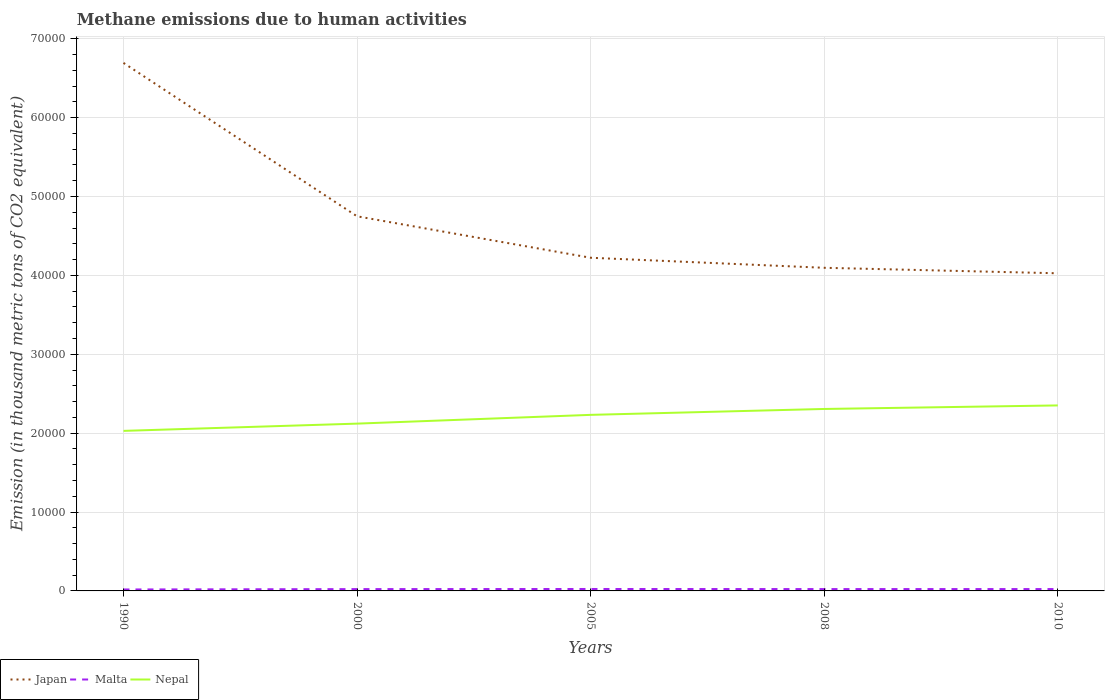Does the line corresponding to Nepal intersect with the line corresponding to Japan?
Ensure brevity in your answer.  No. Across all years, what is the maximum amount of methane emitted in Nepal?
Your answer should be very brief. 2.03e+04. In which year was the amount of methane emitted in Malta maximum?
Make the answer very short. 1990. What is the total amount of methane emitted in Japan in the graph?
Make the answer very short. 1967.7. What is the difference between the highest and the second highest amount of methane emitted in Malta?
Make the answer very short. 61.4. What is the difference between the highest and the lowest amount of methane emitted in Malta?
Make the answer very short. 4. Is the amount of methane emitted in Japan strictly greater than the amount of methane emitted in Malta over the years?
Your answer should be compact. No. How many lines are there?
Your answer should be very brief. 3. Does the graph contain any zero values?
Give a very brief answer. No. What is the title of the graph?
Offer a very short reply. Methane emissions due to human activities. What is the label or title of the Y-axis?
Ensure brevity in your answer.  Emission (in thousand metric tons of CO2 equivalent). What is the Emission (in thousand metric tons of CO2 equivalent) of Japan in 1990?
Offer a terse response. 6.69e+04. What is the Emission (in thousand metric tons of CO2 equivalent) of Malta in 1990?
Give a very brief answer. 183.7. What is the Emission (in thousand metric tons of CO2 equivalent) in Nepal in 1990?
Make the answer very short. 2.03e+04. What is the Emission (in thousand metric tons of CO2 equivalent) in Japan in 2000?
Your answer should be very brief. 4.75e+04. What is the Emission (in thousand metric tons of CO2 equivalent) in Malta in 2000?
Keep it short and to the point. 230.8. What is the Emission (in thousand metric tons of CO2 equivalent) in Nepal in 2000?
Provide a short and direct response. 2.12e+04. What is the Emission (in thousand metric tons of CO2 equivalent) in Japan in 2005?
Keep it short and to the point. 4.22e+04. What is the Emission (in thousand metric tons of CO2 equivalent) in Malta in 2005?
Provide a short and direct response. 245.1. What is the Emission (in thousand metric tons of CO2 equivalent) in Nepal in 2005?
Keep it short and to the point. 2.23e+04. What is the Emission (in thousand metric tons of CO2 equivalent) of Japan in 2008?
Provide a succinct answer. 4.10e+04. What is the Emission (in thousand metric tons of CO2 equivalent) in Malta in 2008?
Provide a short and direct response. 234.5. What is the Emission (in thousand metric tons of CO2 equivalent) of Nepal in 2008?
Make the answer very short. 2.31e+04. What is the Emission (in thousand metric tons of CO2 equivalent) in Japan in 2010?
Keep it short and to the point. 4.03e+04. What is the Emission (in thousand metric tons of CO2 equivalent) of Malta in 2010?
Offer a terse response. 235.4. What is the Emission (in thousand metric tons of CO2 equivalent) of Nepal in 2010?
Give a very brief answer. 2.35e+04. Across all years, what is the maximum Emission (in thousand metric tons of CO2 equivalent) in Japan?
Make the answer very short. 6.69e+04. Across all years, what is the maximum Emission (in thousand metric tons of CO2 equivalent) in Malta?
Offer a terse response. 245.1. Across all years, what is the maximum Emission (in thousand metric tons of CO2 equivalent) in Nepal?
Offer a terse response. 2.35e+04. Across all years, what is the minimum Emission (in thousand metric tons of CO2 equivalent) of Japan?
Provide a short and direct response. 4.03e+04. Across all years, what is the minimum Emission (in thousand metric tons of CO2 equivalent) of Malta?
Your answer should be very brief. 183.7. Across all years, what is the minimum Emission (in thousand metric tons of CO2 equivalent) in Nepal?
Provide a short and direct response. 2.03e+04. What is the total Emission (in thousand metric tons of CO2 equivalent) of Japan in the graph?
Your response must be concise. 2.38e+05. What is the total Emission (in thousand metric tons of CO2 equivalent) in Malta in the graph?
Offer a very short reply. 1129.5. What is the total Emission (in thousand metric tons of CO2 equivalent) in Nepal in the graph?
Give a very brief answer. 1.10e+05. What is the difference between the Emission (in thousand metric tons of CO2 equivalent) in Japan in 1990 and that in 2000?
Your response must be concise. 1.94e+04. What is the difference between the Emission (in thousand metric tons of CO2 equivalent) in Malta in 1990 and that in 2000?
Keep it short and to the point. -47.1. What is the difference between the Emission (in thousand metric tons of CO2 equivalent) of Nepal in 1990 and that in 2000?
Keep it short and to the point. -920.3. What is the difference between the Emission (in thousand metric tons of CO2 equivalent) of Japan in 1990 and that in 2005?
Offer a very short reply. 2.47e+04. What is the difference between the Emission (in thousand metric tons of CO2 equivalent) in Malta in 1990 and that in 2005?
Your answer should be very brief. -61.4. What is the difference between the Emission (in thousand metric tons of CO2 equivalent) in Nepal in 1990 and that in 2005?
Keep it short and to the point. -2031.1. What is the difference between the Emission (in thousand metric tons of CO2 equivalent) of Japan in 1990 and that in 2008?
Your answer should be very brief. 2.60e+04. What is the difference between the Emission (in thousand metric tons of CO2 equivalent) in Malta in 1990 and that in 2008?
Keep it short and to the point. -50.8. What is the difference between the Emission (in thousand metric tons of CO2 equivalent) of Nepal in 1990 and that in 2008?
Ensure brevity in your answer.  -2778.1. What is the difference between the Emission (in thousand metric tons of CO2 equivalent) of Japan in 1990 and that in 2010?
Offer a very short reply. 2.67e+04. What is the difference between the Emission (in thousand metric tons of CO2 equivalent) of Malta in 1990 and that in 2010?
Ensure brevity in your answer.  -51.7. What is the difference between the Emission (in thousand metric tons of CO2 equivalent) in Nepal in 1990 and that in 2010?
Offer a very short reply. -3226.3. What is the difference between the Emission (in thousand metric tons of CO2 equivalent) of Japan in 2000 and that in 2005?
Offer a very short reply. 5254. What is the difference between the Emission (in thousand metric tons of CO2 equivalent) in Malta in 2000 and that in 2005?
Offer a terse response. -14.3. What is the difference between the Emission (in thousand metric tons of CO2 equivalent) of Nepal in 2000 and that in 2005?
Offer a terse response. -1110.8. What is the difference between the Emission (in thousand metric tons of CO2 equivalent) in Japan in 2000 and that in 2008?
Your response must be concise. 6526.6. What is the difference between the Emission (in thousand metric tons of CO2 equivalent) in Malta in 2000 and that in 2008?
Offer a very short reply. -3.7. What is the difference between the Emission (in thousand metric tons of CO2 equivalent) of Nepal in 2000 and that in 2008?
Give a very brief answer. -1857.8. What is the difference between the Emission (in thousand metric tons of CO2 equivalent) of Japan in 2000 and that in 2010?
Your answer should be compact. 7221.7. What is the difference between the Emission (in thousand metric tons of CO2 equivalent) of Nepal in 2000 and that in 2010?
Give a very brief answer. -2306. What is the difference between the Emission (in thousand metric tons of CO2 equivalent) in Japan in 2005 and that in 2008?
Your response must be concise. 1272.6. What is the difference between the Emission (in thousand metric tons of CO2 equivalent) of Nepal in 2005 and that in 2008?
Your answer should be very brief. -747. What is the difference between the Emission (in thousand metric tons of CO2 equivalent) of Japan in 2005 and that in 2010?
Provide a short and direct response. 1967.7. What is the difference between the Emission (in thousand metric tons of CO2 equivalent) in Nepal in 2005 and that in 2010?
Your answer should be compact. -1195.2. What is the difference between the Emission (in thousand metric tons of CO2 equivalent) of Japan in 2008 and that in 2010?
Your answer should be compact. 695.1. What is the difference between the Emission (in thousand metric tons of CO2 equivalent) of Nepal in 2008 and that in 2010?
Your response must be concise. -448.2. What is the difference between the Emission (in thousand metric tons of CO2 equivalent) in Japan in 1990 and the Emission (in thousand metric tons of CO2 equivalent) in Malta in 2000?
Make the answer very short. 6.67e+04. What is the difference between the Emission (in thousand metric tons of CO2 equivalent) in Japan in 1990 and the Emission (in thousand metric tons of CO2 equivalent) in Nepal in 2000?
Keep it short and to the point. 4.57e+04. What is the difference between the Emission (in thousand metric tons of CO2 equivalent) of Malta in 1990 and the Emission (in thousand metric tons of CO2 equivalent) of Nepal in 2000?
Your response must be concise. -2.10e+04. What is the difference between the Emission (in thousand metric tons of CO2 equivalent) of Japan in 1990 and the Emission (in thousand metric tons of CO2 equivalent) of Malta in 2005?
Your response must be concise. 6.67e+04. What is the difference between the Emission (in thousand metric tons of CO2 equivalent) in Japan in 1990 and the Emission (in thousand metric tons of CO2 equivalent) in Nepal in 2005?
Provide a short and direct response. 4.46e+04. What is the difference between the Emission (in thousand metric tons of CO2 equivalent) in Malta in 1990 and the Emission (in thousand metric tons of CO2 equivalent) in Nepal in 2005?
Give a very brief answer. -2.21e+04. What is the difference between the Emission (in thousand metric tons of CO2 equivalent) of Japan in 1990 and the Emission (in thousand metric tons of CO2 equivalent) of Malta in 2008?
Keep it short and to the point. 6.67e+04. What is the difference between the Emission (in thousand metric tons of CO2 equivalent) in Japan in 1990 and the Emission (in thousand metric tons of CO2 equivalent) in Nepal in 2008?
Your answer should be very brief. 4.39e+04. What is the difference between the Emission (in thousand metric tons of CO2 equivalent) in Malta in 1990 and the Emission (in thousand metric tons of CO2 equivalent) in Nepal in 2008?
Your answer should be compact. -2.29e+04. What is the difference between the Emission (in thousand metric tons of CO2 equivalent) in Japan in 1990 and the Emission (in thousand metric tons of CO2 equivalent) in Malta in 2010?
Offer a terse response. 6.67e+04. What is the difference between the Emission (in thousand metric tons of CO2 equivalent) of Japan in 1990 and the Emission (in thousand metric tons of CO2 equivalent) of Nepal in 2010?
Keep it short and to the point. 4.34e+04. What is the difference between the Emission (in thousand metric tons of CO2 equivalent) in Malta in 1990 and the Emission (in thousand metric tons of CO2 equivalent) in Nepal in 2010?
Provide a succinct answer. -2.33e+04. What is the difference between the Emission (in thousand metric tons of CO2 equivalent) in Japan in 2000 and the Emission (in thousand metric tons of CO2 equivalent) in Malta in 2005?
Your answer should be compact. 4.72e+04. What is the difference between the Emission (in thousand metric tons of CO2 equivalent) in Japan in 2000 and the Emission (in thousand metric tons of CO2 equivalent) in Nepal in 2005?
Offer a terse response. 2.52e+04. What is the difference between the Emission (in thousand metric tons of CO2 equivalent) of Malta in 2000 and the Emission (in thousand metric tons of CO2 equivalent) of Nepal in 2005?
Offer a very short reply. -2.21e+04. What is the difference between the Emission (in thousand metric tons of CO2 equivalent) in Japan in 2000 and the Emission (in thousand metric tons of CO2 equivalent) in Malta in 2008?
Ensure brevity in your answer.  4.72e+04. What is the difference between the Emission (in thousand metric tons of CO2 equivalent) in Japan in 2000 and the Emission (in thousand metric tons of CO2 equivalent) in Nepal in 2008?
Give a very brief answer. 2.44e+04. What is the difference between the Emission (in thousand metric tons of CO2 equivalent) of Malta in 2000 and the Emission (in thousand metric tons of CO2 equivalent) of Nepal in 2008?
Ensure brevity in your answer.  -2.28e+04. What is the difference between the Emission (in thousand metric tons of CO2 equivalent) in Japan in 2000 and the Emission (in thousand metric tons of CO2 equivalent) in Malta in 2010?
Provide a succinct answer. 4.72e+04. What is the difference between the Emission (in thousand metric tons of CO2 equivalent) in Japan in 2000 and the Emission (in thousand metric tons of CO2 equivalent) in Nepal in 2010?
Your response must be concise. 2.40e+04. What is the difference between the Emission (in thousand metric tons of CO2 equivalent) in Malta in 2000 and the Emission (in thousand metric tons of CO2 equivalent) in Nepal in 2010?
Provide a succinct answer. -2.33e+04. What is the difference between the Emission (in thousand metric tons of CO2 equivalent) of Japan in 2005 and the Emission (in thousand metric tons of CO2 equivalent) of Malta in 2008?
Your answer should be very brief. 4.20e+04. What is the difference between the Emission (in thousand metric tons of CO2 equivalent) of Japan in 2005 and the Emission (in thousand metric tons of CO2 equivalent) of Nepal in 2008?
Keep it short and to the point. 1.92e+04. What is the difference between the Emission (in thousand metric tons of CO2 equivalent) in Malta in 2005 and the Emission (in thousand metric tons of CO2 equivalent) in Nepal in 2008?
Offer a terse response. -2.28e+04. What is the difference between the Emission (in thousand metric tons of CO2 equivalent) in Japan in 2005 and the Emission (in thousand metric tons of CO2 equivalent) in Malta in 2010?
Keep it short and to the point. 4.20e+04. What is the difference between the Emission (in thousand metric tons of CO2 equivalent) of Japan in 2005 and the Emission (in thousand metric tons of CO2 equivalent) of Nepal in 2010?
Keep it short and to the point. 1.87e+04. What is the difference between the Emission (in thousand metric tons of CO2 equivalent) of Malta in 2005 and the Emission (in thousand metric tons of CO2 equivalent) of Nepal in 2010?
Provide a succinct answer. -2.33e+04. What is the difference between the Emission (in thousand metric tons of CO2 equivalent) in Japan in 2008 and the Emission (in thousand metric tons of CO2 equivalent) in Malta in 2010?
Your answer should be very brief. 4.07e+04. What is the difference between the Emission (in thousand metric tons of CO2 equivalent) in Japan in 2008 and the Emission (in thousand metric tons of CO2 equivalent) in Nepal in 2010?
Provide a succinct answer. 1.74e+04. What is the difference between the Emission (in thousand metric tons of CO2 equivalent) of Malta in 2008 and the Emission (in thousand metric tons of CO2 equivalent) of Nepal in 2010?
Your response must be concise. -2.33e+04. What is the average Emission (in thousand metric tons of CO2 equivalent) in Japan per year?
Give a very brief answer. 4.76e+04. What is the average Emission (in thousand metric tons of CO2 equivalent) of Malta per year?
Make the answer very short. 225.9. What is the average Emission (in thousand metric tons of CO2 equivalent) in Nepal per year?
Make the answer very short. 2.21e+04. In the year 1990, what is the difference between the Emission (in thousand metric tons of CO2 equivalent) of Japan and Emission (in thousand metric tons of CO2 equivalent) of Malta?
Ensure brevity in your answer.  6.67e+04. In the year 1990, what is the difference between the Emission (in thousand metric tons of CO2 equivalent) of Japan and Emission (in thousand metric tons of CO2 equivalent) of Nepal?
Keep it short and to the point. 4.66e+04. In the year 1990, what is the difference between the Emission (in thousand metric tons of CO2 equivalent) in Malta and Emission (in thousand metric tons of CO2 equivalent) in Nepal?
Your response must be concise. -2.01e+04. In the year 2000, what is the difference between the Emission (in thousand metric tons of CO2 equivalent) in Japan and Emission (in thousand metric tons of CO2 equivalent) in Malta?
Keep it short and to the point. 4.73e+04. In the year 2000, what is the difference between the Emission (in thousand metric tons of CO2 equivalent) in Japan and Emission (in thousand metric tons of CO2 equivalent) in Nepal?
Keep it short and to the point. 2.63e+04. In the year 2000, what is the difference between the Emission (in thousand metric tons of CO2 equivalent) in Malta and Emission (in thousand metric tons of CO2 equivalent) in Nepal?
Your response must be concise. -2.10e+04. In the year 2005, what is the difference between the Emission (in thousand metric tons of CO2 equivalent) of Japan and Emission (in thousand metric tons of CO2 equivalent) of Malta?
Provide a succinct answer. 4.20e+04. In the year 2005, what is the difference between the Emission (in thousand metric tons of CO2 equivalent) in Japan and Emission (in thousand metric tons of CO2 equivalent) in Nepal?
Ensure brevity in your answer.  1.99e+04. In the year 2005, what is the difference between the Emission (in thousand metric tons of CO2 equivalent) in Malta and Emission (in thousand metric tons of CO2 equivalent) in Nepal?
Offer a very short reply. -2.21e+04. In the year 2008, what is the difference between the Emission (in thousand metric tons of CO2 equivalent) of Japan and Emission (in thousand metric tons of CO2 equivalent) of Malta?
Make the answer very short. 4.07e+04. In the year 2008, what is the difference between the Emission (in thousand metric tons of CO2 equivalent) in Japan and Emission (in thousand metric tons of CO2 equivalent) in Nepal?
Make the answer very short. 1.79e+04. In the year 2008, what is the difference between the Emission (in thousand metric tons of CO2 equivalent) of Malta and Emission (in thousand metric tons of CO2 equivalent) of Nepal?
Provide a short and direct response. -2.28e+04. In the year 2010, what is the difference between the Emission (in thousand metric tons of CO2 equivalent) in Japan and Emission (in thousand metric tons of CO2 equivalent) in Malta?
Provide a succinct answer. 4.00e+04. In the year 2010, what is the difference between the Emission (in thousand metric tons of CO2 equivalent) of Japan and Emission (in thousand metric tons of CO2 equivalent) of Nepal?
Your answer should be compact. 1.67e+04. In the year 2010, what is the difference between the Emission (in thousand metric tons of CO2 equivalent) of Malta and Emission (in thousand metric tons of CO2 equivalent) of Nepal?
Offer a terse response. -2.33e+04. What is the ratio of the Emission (in thousand metric tons of CO2 equivalent) in Japan in 1990 to that in 2000?
Offer a very short reply. 1.41. What is the ratio of the Emission (in thousand metric tons of CO2 equivalent) in Malta in 1990 to that in 2000?
Offer a terse response. 0.8. What is the ratio of the Emission (in thousand metric tons of CO2 equivalent) of Nepal in 1990 to that in 2000?
Make the answer very short. 0.96. What is the ratio of the Emission (in thousand metric tons of CO2 equivalent) in Japan in 1990 to that in 2005?
Provide a succinct answer. 1.58. What is the ratio of the Emission (in thousand metric tons of CO2 equivalent) of Malta in 1990 to that in 2005?
Provide a succinct answer. 0.75. What is the ratio of the Emission (in thousand metric tons of CO2 equivalent) in Nepal in 1990 to that in 2005?
Ensure brevity in your answer.  0.91. What is the ratio of the Emission (in thousand metric tons of CO2 equivalent) of Japan in 1990 to that in 2008?
Your answer should be very brief. 1.63. What is the ratio of the Emission (in thousand metric tons of CO2 equivalent) in Malta in 1990 to that in 2008?
Give a very brief answer. 0.78. What is the ratio of the Emission (in thousand metric tons of CO2 equivalent) of Nepal in 1990 to that in 2008?
Ensure brevity in your answer.  0.88. What is the ratio of the Emission (in thousand metric tons of CO2 equivalent) of Japan in 1990 to that in 2010?
Your answer should be compact. 1.66. What is the ratio of the Emission (in thousand metric tons of CO2 equivalent) in Malta in 1990 to that in 2010?
Provide a short and direct response. 0.78. What is the ratio of the Emission (in thousand metric tons of CO2 equivalent) in Nepal in 1990 to that in 2010?
Keep it short and to the point. 0.86. What is the ratio of the Emission (in thousand metric tons of CO2 equivalent) of Japan in 2000 to that in 2005?
Your response must be concise. 1.12. What is the ratio of the Emission (in thousand metric tons of CO2 equivalent) in Malta in 2000 to that in 2005?
Offer a very short reply. 0.94. What is the ratio of the Emission (in thousand metric tons of CO2 equivalent) of Nepal in 2000 to that in 2005?
Ensure brevity in your answer.  0.95. What is the ratio of the Emission (in thousand metric tons of CO2 equivalent) in Japan in 2000 to that in 2008?
Ensure brevity in your answer.  1.16. What is the ratio of the Emission (in thousand metric tons of CO2 equivalent) in Malta in 2000 to that in 2008?
Offer a terse response. 0.98. What is the ratio of the Emission (in thousand metric tons of CO2 equivalent) in Nepal in 2000 to that in 2008?
Your answer should be very brief. 0.92. What is the ratio of the Emission (in thousand metric tons of CO2 equivalent) of Japan in 2000 to that in 2010?
Provide a succinct answer. 1.18. What is the ratio of the Emission (in thousand metric tons of CO2 equivalent) of Malta in 2000 to that in 2010?
Keep it short and to the point. 0.98. What is the ratio of the Emission (in thousand metric tons of CO2 equivalent) of Nepal in 2000 to that in 2010?
Offer a very short reply. 0.9. What is the ratio of the Emission (in thousand metric tons of CO2 equivalent) of Japan in 2005 to that in 2008?
Your response must be concise. 1.03. What is the ratio of the Emission (in thousand metric tons of CO2 equivalent) in Malta in 2005 to that in 2008?
Your answer should be compact. 1.05. What is the ratio of the Emission (in thousand metric tons of CO2 equivalent) of Nepal in 2005 to that in 2008?
Your response must be concise. 0.97. What is the ratio of the Emission (in thousand metric tons of CO2 equivalent) of Japan in 2005 to that in 2010?
Keep it short and to the point. 1.05. What is the ratio of the Emission (in thousand metric tons of CO2 equivalent) of Malta in 2005 to that in 2010?
Your answer should be very brief. 1.04. What is the ratio of the Emission (in thousand metric tons of CO2 equivalent) in Nepal in 2005 to that in 2010?
Provide a succinct answer. 0.95. What is the ratio of the Emission (in thousand metric tons of CO2 equivalent) of Japan in 2008 to that in 2010?
Ensure brevity in your answer.  1.02. What is the ratio of the Emission (in thousand metric tons of CO2 equivalent) in Nepal in 2008 to that in 2010?
Your response must be concise. 0.98. What is the difference between the highest and the second highest Emission (in thousand metric tons of CO2 equivalent) of Japan?
Provide a short and direct response. 1.94e+04. What is the difference between the highest and the second highest Emission (in thousand metric tons of CO2 equivalent) of Malta?
Make the answer very short. 9.7. What is the difference between the highest and the second highest Emission (in thousand metric tons of CO2 equivalent) in Nepal?
Make the answer very short. 448.2. What is the difference between the highest and the lowest Emission (in thousand metric tons of CO2 equivalent) in Japan?
Keep it short and to the point. 2.67e+04. What is the difference between the highest and the lowest Emission (in thousand metric tons of CO2 equivalent) of Malta?
Your answer should be very brief. 61.4. What is the difference between the highest and the lowest Emission (in thousand metric tons of CO2 equivalent) in Nepal?
Provide a succinct answer. 3226.3. 